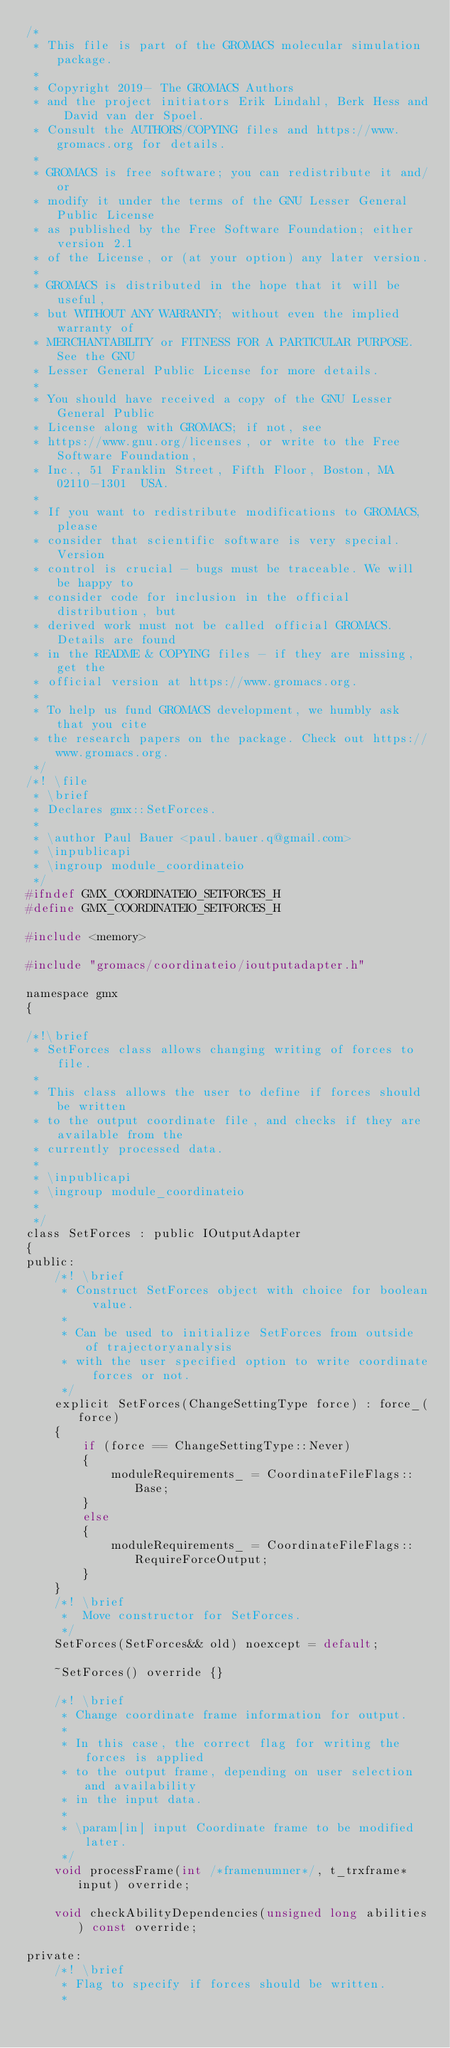<code> <loc_0><loc_0><loc_500><loc_500><_C_>/*
 * This file is part of the GROMACS molecular simulation package.
 *
 * Copyright 2019- The GROMACS Authors
 * and the project initiators Erik Lindahl, Berk Hess and David van der Spoel.
 * Consult the AUTHORS/COPYING files and https://www.gromacs.org for details.
 *
 * GROMACS is free software; you can redistribute it and/or
 * modify it under the terms of the GNU Lesser General Public License
 * as published by the Free Software Foundation; either version 2.1
 * of the License, or (at your option) any later version.
 *
 * GROMACS is distributed in the hope that it will be useful,
 * but WITHOUT ANY WARRANTY; without even the implied warranty of
 * MERCHANTABILITY or FITNESS FOR A PARTICULAR PURPOSE.  See the GNU
 * Lesser General Public License for more details.
 *
 * You should have received a copy of the GNU Lesser General Public
 * License along with GROMACS; if not, see
 * https://www.gnu.org/licenses, or write to the Free Software Foundation,
 * Inc., 51 Franklin Street, Fifth Floor, Boston, MA  02110-1301  USA.
 *
 * If you want to redistribute modifications to GROMACS, please
 * consider that scientific software is very special. Version
 * control is crucial - bugs must be traceable. We will be happy to
 * consider code for inclusion in the official distribution, but
 * derived work must not be called official GROMACS. Details are found
 * in the README & COPYING files - if they are missing, get the
 * official version at https://www.gromacs.org.
 *
 * To help us fund GROMACS development, we humbly ask that you cite
 * the research papers on the package. Check out https://www.gromacs.org.
 */
/*! \file
 * \brief
 * Declares gmx::SetForces.
 *
 * \author Paul Bauer <paul.bauer.q@gmail.com>
 * \inpublicapi
 * \ingroup module_coordinateio
 */
#ifndef GMX_COORDINATEIO_SETFORCES_H
#define GMX_COORDINATEIO_SETFORCES_H

#include <memory>

#include "gromacs/coordinateio/ioutputadapter.h"

namespace gmx
{

/*!\brief
 * SetForces class allows changing writing of forces to file.
 *
 * This class allows the user to define if forces should be written
 * to the output coordinate file, and checks if they are available from the
 * currently processed data.
 *
 * \inpublicapi
 * \ingroup module_coordinateio
 *
 */
class SetForces : public IOutputAdapter
{
public:
    /*! \brief
     * Construct SetForces object with choice for boolean value.
     *
     * Can be used to initialize SetForces from outside of trajectoryanalysis
     * with the user specified option to write coordinate forces or not.
     */
    explicit SetForces(ChangeSettingType force) : force_(force)
    {
        if (force == ChangeSettingType::Never)
        {
            moduleRequirements_ = CoordinateFileFlags::Base;
        }
        else
        {
            moduleRequirements_ = CoordinateFileFlags::RequireForceOutput;
        }
    }
    /*! \brief
     *  Move constructor for SetForces.
     */
    SetForces(SetForces&& old) noexcept = default;

    ~SetForces() override {}

    /*! \brief
     * Change coordinate frame information for output.
     *
     * In this case, the correct flag for writing the forces is applied
     * to the output frame, depending on user selection and availability
     * in the input data.
     *
     * \param[in] input Coordinate frame to be modified later.
     */
    void processFrame(int /*framenumner*/, t_trxframe* input) override;

    void checkAbilityDependencies(unsigned long abilities) const override;

private:
    /*! \brief
     * Flag to specify if forces should be written.
     *</code> 